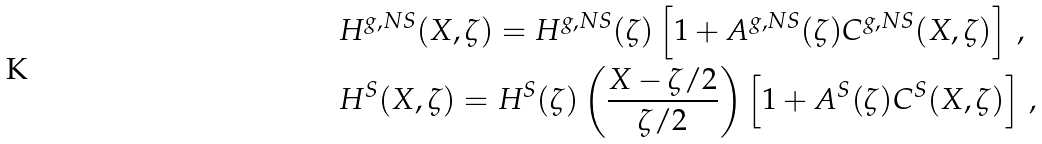<formula> <loc_0><loc_0><loc_500><loc_500>& H ^ { g , N S } ( X , \zeta ) = H ^ { g , N S } ( \zeta ) \left [ 1 + A ^ { g , N S } ( \zeta ) C ^ { g , N S } ( X , \zeta ) \right ] \, , \\ & H ^ { S } ( X , \zeta ) = H ^ { S } ( \zeta ) \left ( \frac { X - \zeta / 2 } { \zeta / 2 } \right ) \left [ 1 + A ^ { S } ( \zeta ) C ^ { S } ( X , \zeta ) \right ] \, ,</formula> 